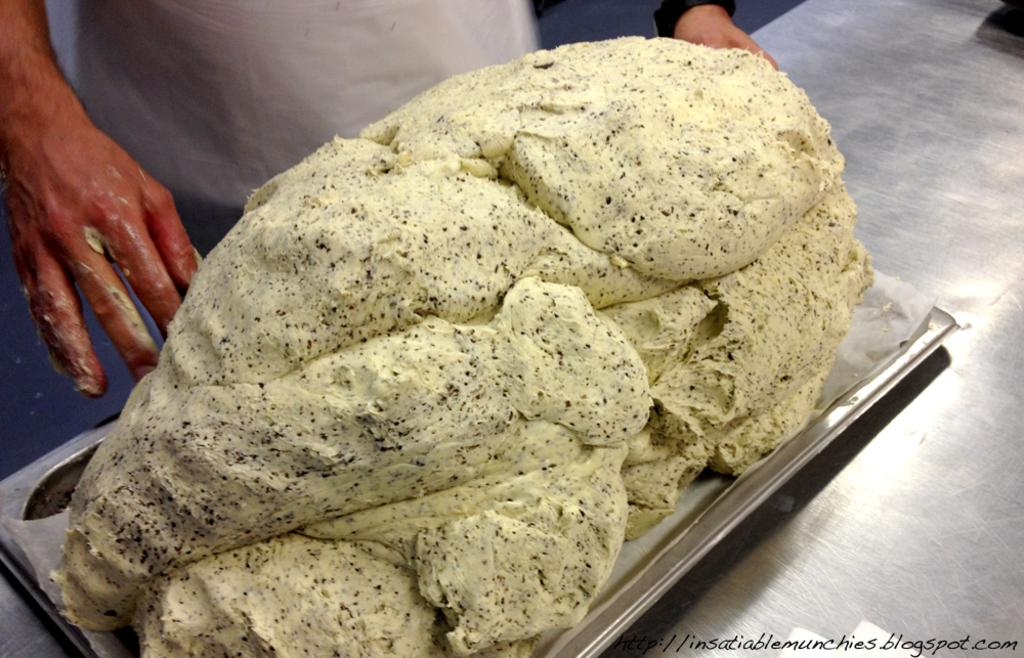What is the person in the image doing? The person is standing behind a table. What is on the table in the image? There is dough on a plate on the table. Where is the plate with dough located? The plate with dough is on the table. What can be found in the bottom right corner of the image? There is text in the bottom right corner of the image. What type of machine is present in the image? There is no machine present in the image. 